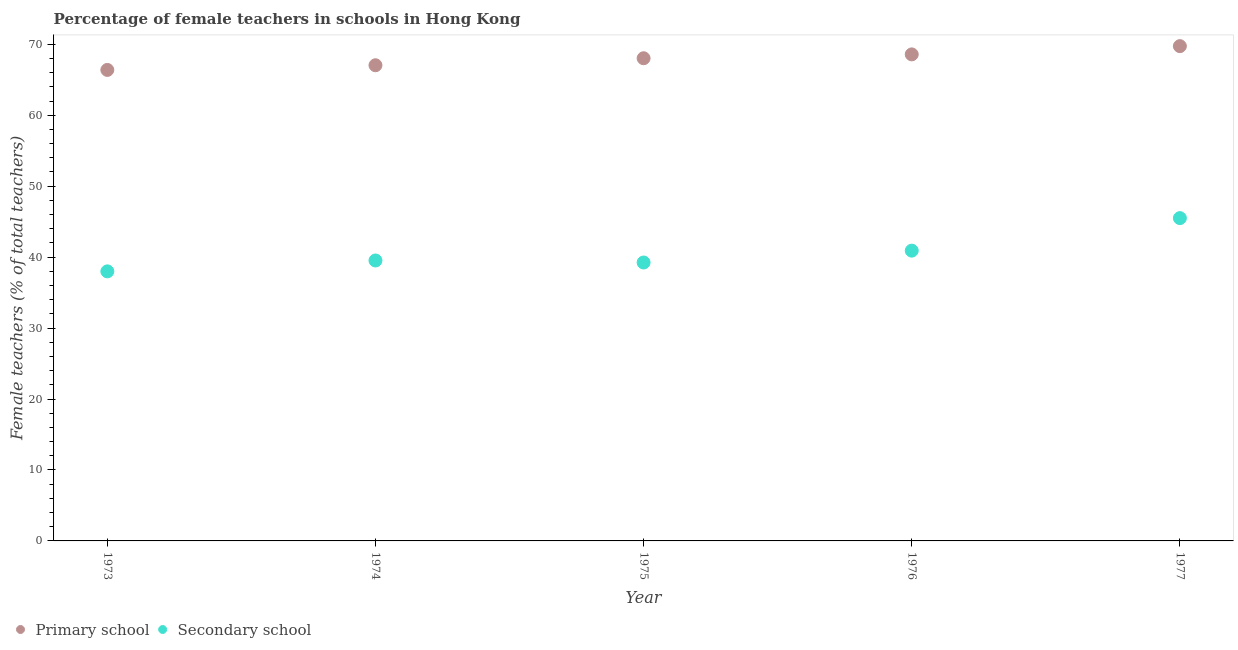How many different coloured dotlines are there?
Your answer should be compact. 2. Is the number of dotlines equal to the number of legend labels?
Provide a short and direct response. Yes. What is the percentage of female teachers in primary schools in 1976?
Offer a very short reply. 68.58. Across all years, what is the maximum percentage of female teachers in secondary schools?
Keep it short and to the point. 45.5. Across all years, what is the minimum percentage of female teachers in secondary schools?
Give a very brief answer. 37.99. In which year was the percentage of female teachers in secondary schools maximum?
Provide a short and direct response. 1977. What is the total percentage of female teachers in secondary schools in the graph?
Provide a succinct answer. 203.18. What is the difference between the percentage of female teachers in primary schools in 1975 and that in 1977?
Your answer should be very brief. -1.71. What is the difference between the percentage of female teachers in secondary schools in 1975 and the percentage of female teachers in primary schools in 1977?
Provide a short and direct response. -30.5. What is the average percentage of female teachers in primary schools per year?
Ensure brevity in your answer.  67.96. In the year 1974, what is the difference between the percentage of female teachers in secondary schools and percentage of female teachers in primary schools?
Offer a terse response. -27.52. In how many years, is the percentage of female teachers in primary schools greater than 50 %?
Provide a short and direct response. 5. What is the ratio of the percentage of female teachers in primary schools in 1974 to that in 1975?
Offer a very short reply. 0.99. Is the difference between the percentage of female teachers in secondary schools in 1974 and 1976 greater than the difference between the percentage of female teachers in primary schools in 1974 and 1976?
Provide a short and direct response. Yes. What is the difference between the highest and the second highest percentage of female teachers in primary schools?
Keep it short and to the point. 1.16. What is the difference between the highest and the lowest percentage of female teachers in primary schools?
Ensure brevity in your answer.  3.35. Does the percentage of female teachers in primary schools monotonically increase over the years?
Your response must be concise. Yes. Is the percentage of female teachers in secondary schools strictly less than the percentage of female teachers in primary schools over the years?
Offer a very short reply. Yes. How many dotlines are there?
Give a very brief answer. 2. What is the difference between two consecutive major ticks on the Y-axis?
Ensure brevity in your answer.  10. Does the graph contain grids?
Give a very brief answer. No. Where does the legend appear in the graph?
Keep it short and to the point. Bottom left. How many legend labels are there?
Provide a short and direct response. 2. How are the legend labels stacked?
Ensure brevity in your answer.  Horizontal. What is the title of the graph?
Make the answer very short. Percentage of female teachers in schools in Hong Kong. What is the label or title of the X-axis?
Provide a succinct answer. Year. What is the label or title of the Y-axis?
Provide a succinct answer. Female teachers (% of total teachers). What is the Female teachers (% of total teachers) in Primary school in 1973?
Provide a short and direct response. 66.39. What is the Female teachers (% of total teachers) in Secondary school in 1973?
Give a very brief answer. 37.99. What is the Female teachers (% of total teachers) of Primary school in 1974?
Keep it short and to the point. 67.04. What is the Female teachers (% of total teachers) in Secondary school in 1974?
Offer a terse response. 39.53. What is the Female teachers (% of total teachers) in Primary school in 1975?
Provide a succinct answer. 68.03. What is the Female teachers (% of total teachers) in Secondary school in 1975?
Ensure brevity in your answer.  39.24. What is the Female teachers (% of total teachers) of Primary school in 1976?
Make the answer very short. 68.58. What is the Female teachers (% of total teachers) of Secondary school in 1976?
Offer a very short reply. 40.91. What is the Female teachers (% of total teachers) in Primary school in 1977?
Give a very brief answer. 69.74. What is the Female teachers (% of total teachers) of Secondary school in 1977?
Offer a very short reply. 45.5. Across all years, what is the maximum Female teachers (% of total teachers) of Primary school?
Your response must be concise. 69.74. Across all years, what is the maximum Female teachers (% of total teachers) in Secondary school?
Your answer should be compact. 45.5. Across all years, what is the minimum Female teachers (% of total teachers) of Primary school?
Offer a terse response. 66.39. Across all years, what is the minimum Female teachers (% of total teachers) of Secondary school?
Your answer should be very brief. 37.99. What is the total Female teachers (% of total teachers) in Primary school in the graph?
Ensure brevity in your answer.  339.78. What is the total Female teachers (% of total teachers) in Secondary school in the graph?
Provide a succinct answer. 203.18. What is the difference between the Female teachers (% of total teachers) in Primary school in 1973 and that in 1974?
Give a very brief answer. -0.66. What is the difference between the Female teachers (% of total teachers) in Secondary school in 1973 and that in 1974?
Provide a short and direct response. -1.53. What is the difference between the Female teachers (% of total teachers) of Primary school in 1973 and that in 1975?
Offer a terse response. -1.65. What is the difference between the Female teachers (% of total teachers) of Secondary school in 1973 and that in 1975?
Provide a succinct answer. -1.25. What is the difference between the Female teachers (% of total teachers) in Primary school in 1973 and that in 1976?
Offer a terse response. -2.19. What is the difference between the Female teachers (% of total teachers) in Secondary school in 1973 and that in 1976?
Offer a very short reply. -2.92. What is the difference between the Female teachers (% of total teachers) in Primary school in 1973 and that in 1977?
Your answer should be very brief. -3.35. What is the difference between the Female teachers (% of total teachers) in Secondary school in 1973 and that in 1977?
Provide a succinct answer. -7.51. What is the difference between the Female teachers (% of total teachers) in Primary school in 1974 and that in 1975?
Provide a succinct answer. -0.99. What is the difference between the Female teachers (% of total teachers) of Secondary school in 1974 and that in 1975?
Your answer should be compact. 0.29. What is the difference between the Female teachers (% of total teachers) of Primary school in 1974 and that in 1976?
Your answer should be very brief. -1.53. What is the difference between the Female teachers (% of total teachers) in Secondary school in 1974 and that in 1976?
Offer a very short reply. -1.39. What is the difference between the Female teachers (% of total teachers) in Primary school in 1974 and that in 1977?
Offer a very short reply. -2.69. What is the difference between the Female teachers (% of total teachers) of Secondary school in 1974 and that in 1977?
Ensure brevity in your answer.  -5.97. What is the difference between the Female teachers (% of total teachers) of Primary school in 1975 and that in 1976?
Provide a succinct answer. -0.54. What is the difference between the Female teachers (% of total teachers) in Secondary school in 1975 and that in 1976?
Keep it short and to the point. -1.67. What is the difference between the Female teachers (% of total teachers) in Primary school in 1975 and that in 1977?
Your response must be concise. -1.71. What is the difference between the Female teachers (% of total teachers) in Secondary school in 1975 and that in 1977?
Ensure brevity in your answer.  -6.26. What is the difference between the Female teachers (% of total teachers) of Primary school in 1976 and that in 1977?
Provide a short and direct response. -1.16. What is the difference between the Female teachers (% of total teachers) of Secondary school in 1976 and that in 1977?
Give a very brief answer. -4.59. What is the difference between the Female teachers (% of total teachers) in Primary school in 1973 and the Female teachers (% of total teachers) in Secondary school in 1974?
Your response must be concise. 26.86. What is the difference between the Female teachers (% of total teachers) of Primary school in 1973 and the Female teachers (% of total teachers) of Secondary school in 1975?
Keep it short and to the point. 27.14. What is the difference between the Female teachers (% of total teachers) of Primary school in 1973 and the Female teachers (% of total teachers) of Secondary school in 1976?
Provide a short and direct response. 25.47. What is the difference between the Female teachers (% of total teachers) of Primary school in 1973 and the Female teachers (% of total teachers) of Secondary school in 1977?
Give a very brief answer. 20.89. What is the difference between the Female teachers (% of total teachers) of Primary school in 1974 and the Female teachers (% of total teachers) of Secondary school in 1975?
Keep it short and to the point. 27.8. What is the difference between the Female teachers (% of total teachers) in Primary school in 1974 and the Female teachers (% of total teachers) in Secondary school in 1976?
Provide a short and direct response. 26.13. What is the difference between the Female teachers (% of total teachers) in Primary school in 1974 and the Female teachers (% of total teachers) in Secondary school in 1977?
Offer a terse response. 21.54. What is the difference between the Female teachers (% of total teachers) of Primary school in 1975 and the Female teachers (% of total teachers) of Secondary school in 1976?
Provide a succinct answer. 27.12. What is the difference between the Female teachers (% of total teachers) in Primary school in 1975 and the Female teachers (% of total teachers) in Secondary school in 1977?
Your answer should be very brief. 22.53. What is the difference between the Female teachers (% of total teachers) in Primary school in 1976 and the Female teachers (% of total teachers) in Secondary school in 1977?
Your answer should be compact. 23.08. What is the average Female teachers (% of total teachers) in Primary school per year?
Ensure brevity in your answer.  67.96. What is the average Female teachers (% of total teachers) of Secondary school per year?
Offer a very short reply. 40.64. In the year 1973, what is the difference between the Female teachers (% of total teachers) of Primary school and Female teachers (% of total teachers) of Secondary school?
Offer a terse response. 28.39. In the year 1974, what is the difference between the Female teachers (% of total teachers) of Primary school and Female teachers (% of total teachers) of Secondary school?
Keep it short and to the point. 27.52. In the year 1975, what is the difference between the Female teachers (% of total teachers) of Primary school and Female teachers (% of total teachers) of Secondary school?
Provide a succinct answer. 28.79. In the year 1976, what is the difference between the Female teachers (% of total teachers) of Primary school and Female teachers (% of total teachers) of Secondary school?
Provide a short and direct response. 27.66. In the year 1977, what is the difference between the Female teachers (% of total teachers) in Primary school and Female teachers (% of total teachers) in Secondary school?
Your answer should be compact. 24.24. What is the ratio of the Female teachers (% of total teachers) in Primary school in 1973 to that in 1974?
Give a very brief answer. 0.99. What is the ratio of the Female teachers (% of total teachers) in Secondary school in 1973 to that in 1974?
Your response must be concise. 0.96. What is the ratio of the Female teachers (% of total teachers) in Primary school in 1973 to that in 1975?
Keep it short and to the point. 0.98. What is the ratio of the Female teachers (% of total teachers) of Secondary school in 1973 to that in 1975?
Offer a terse response. 0.97. What is the ratio of the Female teachers (% of total teachers) in Primary school in 1973 to that in 1976?
Your answer should be compact. 0.97. What is the ratio of the Female teachers (% of total teachers) of Secondary school in 1973 to that in 1976?
Ensure brevity in your answer.  0.93. What is the ratio of the Female teachers (% of total teachers) of Primary school in 1973 to that in 1977?
Provide a succinct answer. 0.95. What is the ratio of the Female teachers (% of total teachers) of Secondary school in 1973 to that in 1977?
Provide a short and direct response. 0.83. What is the ratio of the Female teachers (% of total teachers) of Primary school in 1974 to that in 1975?
Provide a succinct answer. 0.99. What is the ratio of the Female teachers (% of total teachers) of Secondary school in 1974 to that in 1975?
Keep it short and to the point. 1.01. What is the ratio of the Female teachers (% of total teachers) in Primary school in 1974 to that in 1976?
Keep it short and to the point. 0.98. What is the ratio of the Female teachers (% of total teachers) in Secondary school in 1974 to that in 1976?
Your answer should be very brief. 0.97. What is the ratio of the Female teachers (% of total teachers) of Primary school in 1974 to that in 1977?
Make the answer very short. 0.96. What is the ratio of the Female teachers (% of total teachers) of Secondary school in 1974 to that in 1977?
Make the answer very short. 0.87. What is the ratio of the Female teachers (% of total teachers) of Secondary school in 1975 to that in 1976?
Offer a very short reply. 0.96. What is the ratio of the Female teachers (% of total teachers) in Primary school in 1975 to that in 1977?
Your answer should be very brief. 0.98. What is the ratio of the Female teachers (% of total teachers) of Secondary school in 1975 to that in 1977?
Offer a terse response. 0.86. What is the ratio of the Female teachers (% of total teachers) of Primary school in 1976 to that in 1977?
Offer a terse response. 0.98. What is the ratio of the Female teachers (% of total teachers) in Secondary school in 1976 to that in 1977?
Offer a terse response. 0.9. What is the difference between the highest and the second highest Female teachers (% of total teachers) of Primary school?
Give a very brief answer. 1.16. What is the difference between the highest and the second highest Female teachers (% of total teachers) of Secondary school?
Provide a succinct answer. 4.59. What is the difference between the highest and the lowest Female teachers (% of total teachers) of Primary school?
Your answer should be compact. 3.35. What is the difference between the highest and the lowest Female teachers (% of total teachers) in Secondary school?
Give a very brief answer. 7.51. 